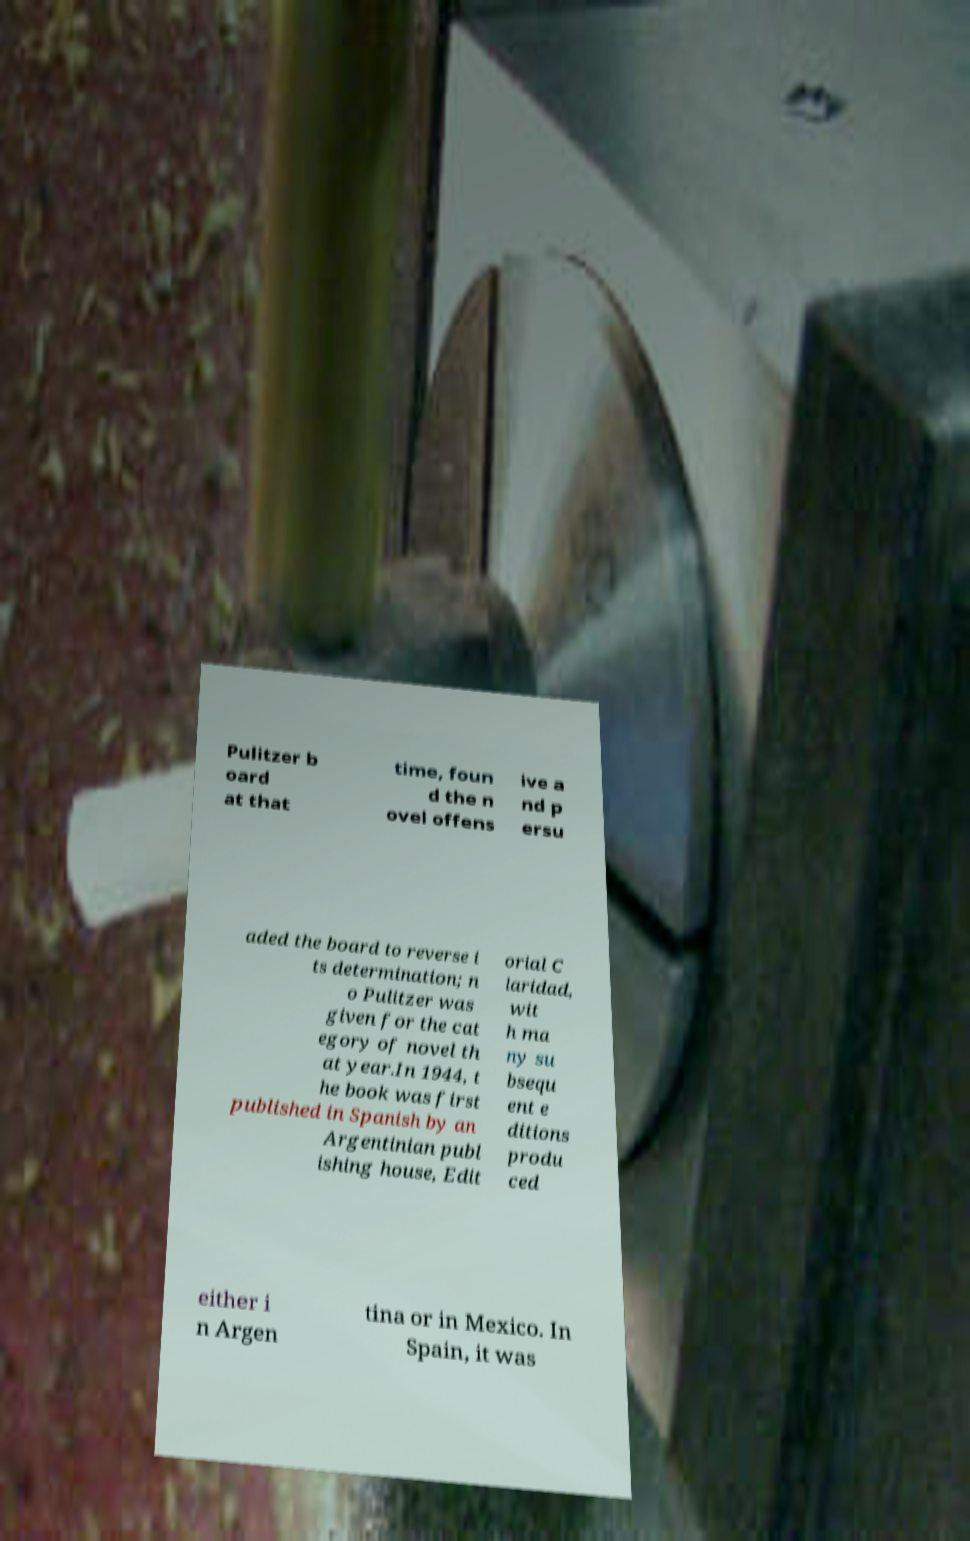There's text embedded in this image that I need extracted. Can you transcribe it verbatim? Pulitzer b oard at that time, foun d the n ovel offens ive a nd p ersu aded the board to reverse i ts determination; n o Pulitzer was given for the cat egory of novel th at year.In 1944, t he book was first published in Spanish by an Argentinian publ ishing house, Edit orial C laridad, wit h ma ny su bsequ ent e ditions produ ced either i n Argen tina or in Mexico. In Spain, it was 